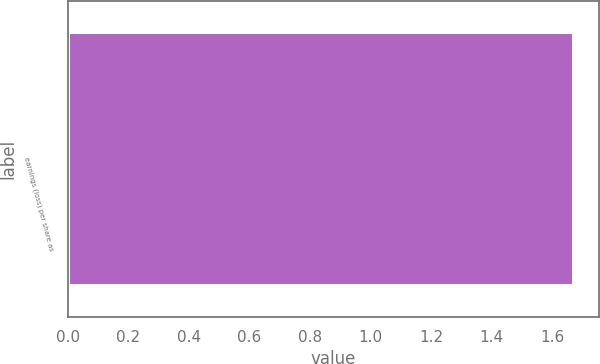<chart> <loc_0><loc_0><loc_500><loc_500><bar_chart><fcel>earnings (loss) per share as<nl><fcel>1.67<nl></chart> 